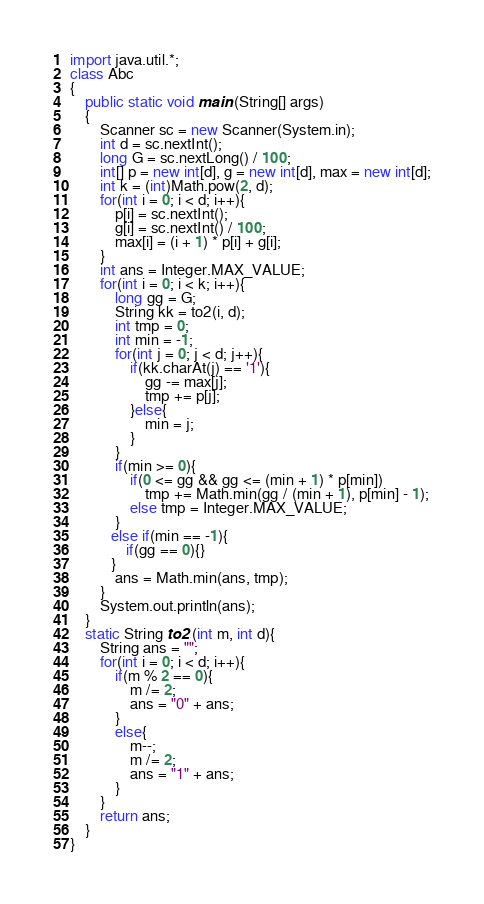Convert code to text. <code><loc_0><loc_0><loc_500><loc_500><_Java_>import java.util.*;
class Abc
{
    public static void main (String[] args)
    {
        Scanner sc = new Scanner(System.in);
        int d = sc.nextInt();
        long G = sc.nextLong() / 100;
        int[] p = new int[d], g = new int[d], max = new int[d];
        int k = (int)Math.pow(2, d);
        for(int i = 0; i < d; i++){
            p[i] = sc.nextInt();
            g[i] = sc.nextInt() / 100;
            max[i] = (i + 1) * p[i] + g[i];
        }
        int ans = Integer.MAX_VALUE;
        for(int i = 0; i < k; i++){
            long gg = G;
            String kk = to2(i, d);
            int tmp = 0;
            int min = -1;
            for(int j = 0; j < d; j++){
                if(kk.charAt(j) == '1'){
                    gg -= max[j];
                    tmp += p[j];
                }else{
                    min = j;
                }
            }
            if(min >= 0){
                if(0 <= gg && gg <= (min + 1) * p[min])
                    tmp += Math.min(gg / (min + 1), p[min] - 1);
                else tmp = Integer.MAX_VALUE;
            }
           else if(min == -1){
               if(gg == 0){}
           }
            ans = Math.min(ans, tmp);
        }
        System.out.println(ans);
    }
    static String to2 (int m, int d){
        String ans = "";
        for(int i = 0; i < d; i++){
            if(m % 2 == 0){
                m /= 2;
                ans = "0" + ans;
            }
            else{
                m--;
                m /= 2;
                ans = "1" + ans;
            }
        }
        return ans;
    }
}</code> 